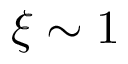Convert formula to latex. <formula><loc_0><loc_0><loc_500><loc_500>\xi \sim 1</formula> 